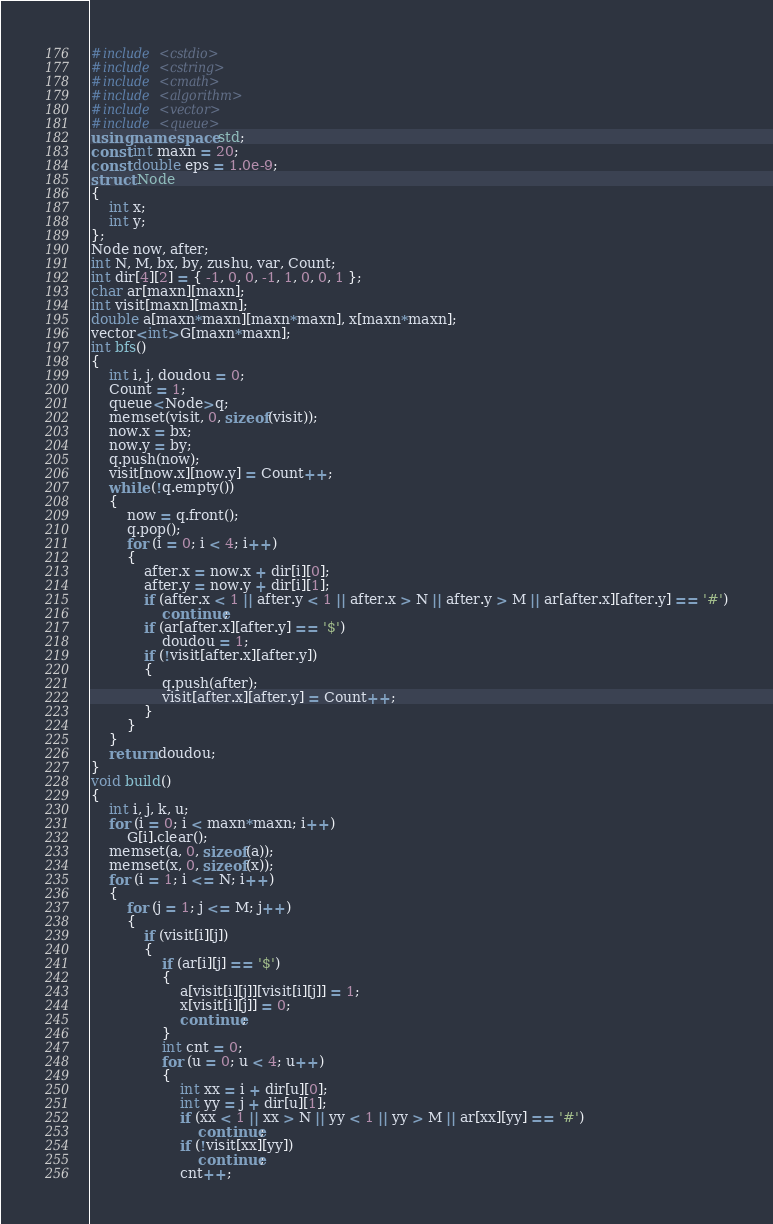<code> <loc_0><loc_0><loc_500><loc_500><_C++_>#include <cstdio>
#include <cstring>
#include <cmath>
#include <algorithm>
#include <vector>
#include <queue>
using namespace std;
const int maxn = 20;
const double eps = 1.0e-9;
struct Node
{
	int x;
	int y;
};
Node now, after;
int N, M, bx, by, zushu, var, Count;
int dir[4][2] = { -1, 0, 0, -1, 1, 0, 0, 1 };
char ar[maxn][maxn];
int visit[maxn][maxn];
double a[maxn*maxn][maxn*maxn], x[maxn*maxn];
vector<int>G[maxn*maxn];
int bfs()
{
	int i, j, doudou = 0;
	Count = 1;
	queue<Node>q;
	memset(visit, 0, sizeof(visit));
	now.x = bx;
	now.y = by;
	q.push(now);
	visit[now.x][now.y] = Count++;
	while (!q.empty())
	{
		now = q.front();
		q.pop();
		for (i = 0; i < 4; i++)
		{
			after.x = now.x + dir[i][0];
			after.y = now.y + dir[i][1];
			if (after.x < 1 || after.y < 1 || after.x > N || after.y > M || ar[after.x][after.y] == '#')
				continue;
			if (ar[after.x][after.y] == '$')
				doudou = 1;
			if (!visit[after.x][after.y])
			{
				q.push(after);
				visit[after.x][after.y] = Count++;
			}
		}
	}
	return doudou;
}
void build()
{
	int i, j, k, u;
	for (i = 0; i < maxn*maxn; i++)
		G[i].clear();
	memset(a, 0, sizeof(a));
	memset(x, 0, sizeof(x));
	for (i = 1; i <= N; i++)
	{
		for (j = 1; j <= M; j++)
		{
			if (visit[i][j])
			{
				if (ar[i][j] == '$')
				{
					a[visit[i][j]][visit[i][j]] = 1;
					x[visit[i][j]] = 0;
					continue;
				}
				int cnt = 0;
				for (u = 0; u < 4; u++)
				{
					int xx = i + dir[u][0];
					int yy = j + dir[u][1];
					if (xx < 1 || xx > N || yy < 1 || yy > M || ar[xx][yy] == '#')
						continue;
					if (!visit[xx][yy])
						continue;
					cnt++;</code> 